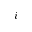<formula> <loc_0><loc_0><loc_500><loc_500>i</formula> 